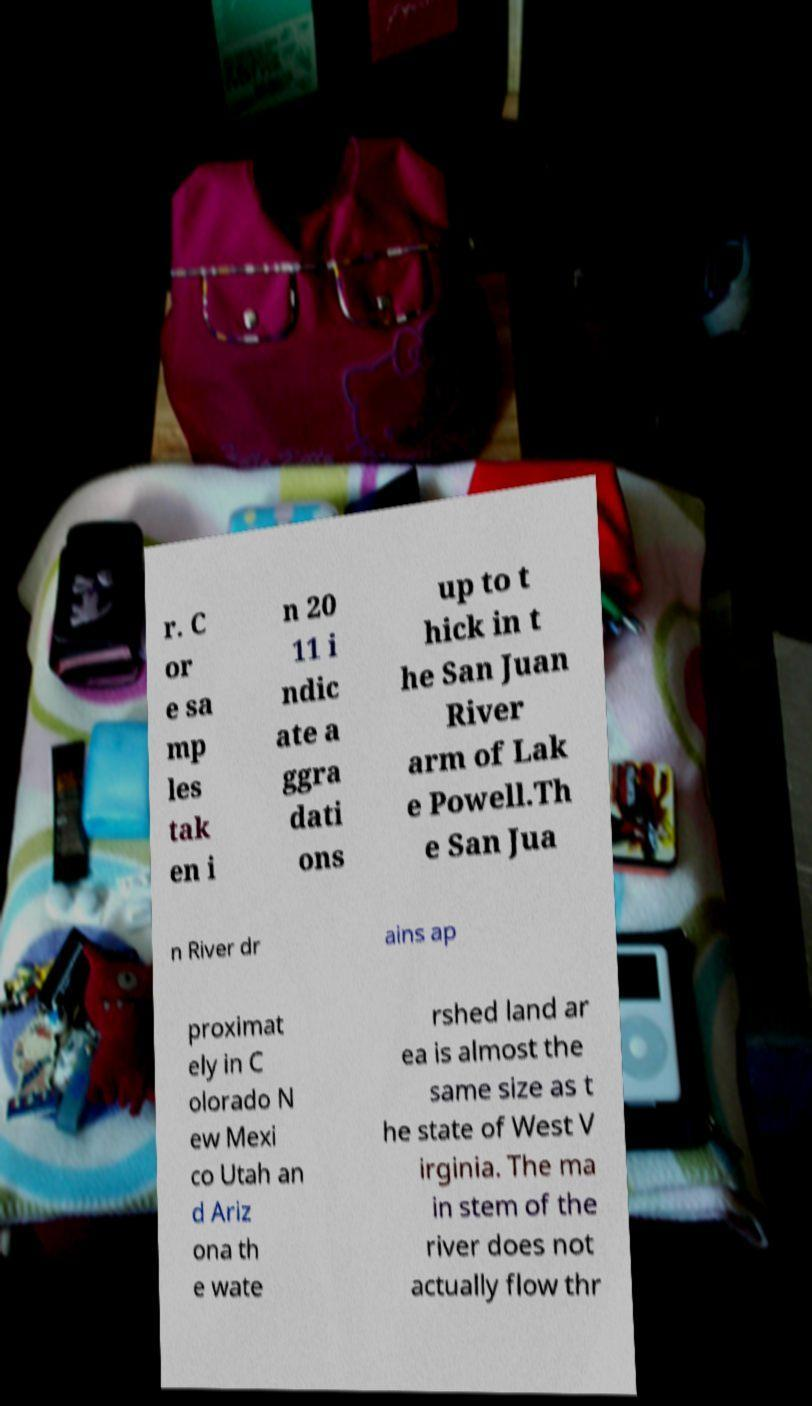What messages or text are displayed in this image? I need them in a readable, typed format. r. C or e sa mp les tak en i n 20 11 i ndic ate a ggra dati ons up to t hick in t he San Juan River arm of Lak e Powell.Th e San Jua n River dr ains ap proximat ely in C olorado N ew Mexi co Utah an d Ariz ona th e wate rshed land ar ea is almost the same size as t he state of West V irginia. The ma in stem of the river does not actually flow thr 